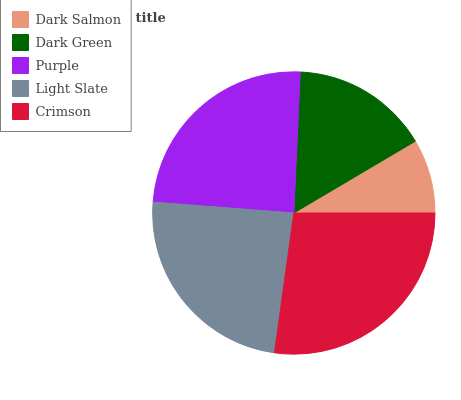Is Dark Salmon the minimum?
Answer yes or no. Yes. Is Crimson the maximum?
Answer yes or no. Yes. Is Dark Green the minimum?
Answer yes or no. No. Is Dark Green the maximum?
Answer yes or no. No. Is Dark Green greater than Dark Salmon?
Answer yes or no. Yes. Is Dark Salmon less than Dark Green?
Answer yes or no. Yes. Is Dark Salmon greater than Dark Green?
Answer yes or no. No. Is Dark Green less than Dark Salmon?
Answer yes or no. No. Is Light Slate the high median?
Answer yes or no. Yes. Is Light Slate the low median?
Answer yes or no. Yes. Is Dark Salmon the high median?
Answer yes or no. No. Is Purple the low median?
Answer yes or no. No. 